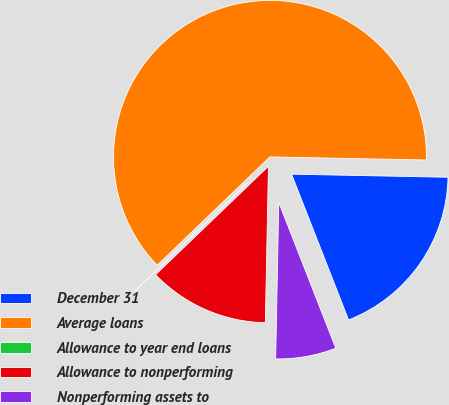Convert chart to OTSL. <chart><loc_0><loc_0><loc_500><loc_500><pie_chart><fcel>December 31<fcel>Average loans<fcel>Allowance to year end loans<fcel>Allowance to nonperforming<fcel>Nonperforming assets to<nl><fcel>18.75%<fcel>62.5%<fcel>0.0%<fcel>12.5%<fcel>6.25%<nl></chart> 